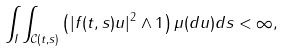<formula> <loc_0><loc_0><loc_500><loc_500>\int _ { I } \int _ { \mathcal { C } ( t , s ) } \left ( | f ( t , s ) u | ^ { 2 } \wedge 1 \right ) \mu ( d u ) d s < \infty ,</formula> 